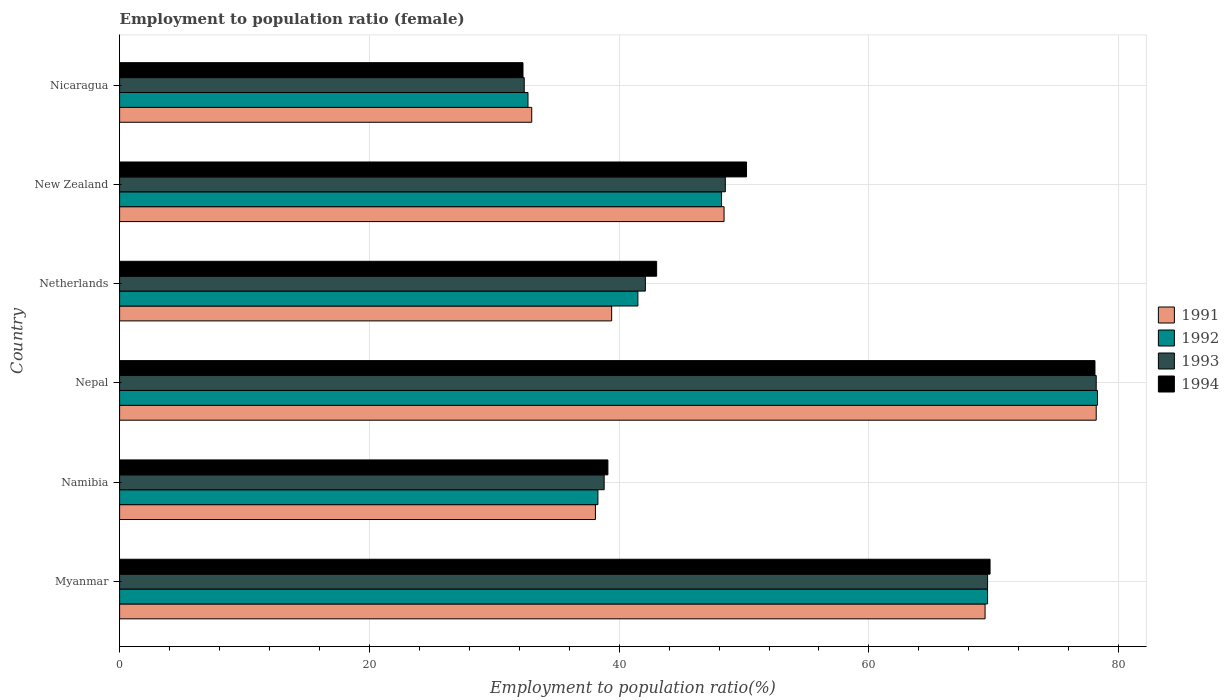Are the number of bars per tick equal to the number of legend labels?
Your answer should be compact. Yes. Are the number of bars on each tick of the Y-axis equal?
Keep it short and to the point. Yes. How many bars are there on the 3rd tick from the bottom?
Give a very brief answer. 4. What is the label of the 6th group of bars from the top?
Provide a succinct answer. Myanmar. In how many cases, is the number of bars for a given country not equal to the number of legend labels?
Make the answer very short. 0. What is the employment to population ratio in 1994 in Myanmar?
Make the answer very short. 69.7. Across all countries, what is the maximum employment to population ratio in 1994?
Offer a terse response. 78.1. Across all countries, what is the minimum employment to population ratio in 1993?
Give a very brief answer. 32.4. In which country was the employment to population ratio in 1993 maximum?
Offer a terse response. Nepal. In which country was the employment to population ratio in 1991 minimum?
Your answer should be very brief. Nicaragua. What is the total employment to population ratio in 1992 in the graph?
Offer a very short reply. 308.5. What is the difference between the employment to population ratio in 1992 in Namibia and that in New Zealand?
Offer a terse response. -9.9. What is the difference between the employment to population ratio in 1993 in Namibia and the employment to population ratio in 1994 in Netherlands?
Your answer should be very brief. -4.2. What is the average employment to population ratio in 1994 per country?
Make the answer very short. 52.07. What is the ratio of the employment to population ratio in 1993 in Myanmar to that in New Zealand?
Ensure brevity in your answer.  1.43. Is the difference between the employment to population ratio in 1992 in Myanmar and Nepal greater than the difference between the employment to population ratio in 1993 in Myanmar and Nepal?
Offer a terse response. No. What is the difference between the highest and the second highest employment to population ratio in 1993?
Your answer should be very brief. 8.7. What is the difference between the highest and the lowest employment to population ratio in 1991?
Your answer should be compact. 45.2. Is the sum of the employment to population ratio in 1994 in Namibia and Nicaragua greater than the maximum employment to population ratio in 1992 across all countries?
Your answer should be compact. No. What does the 2nd bar from the top in Nepal represents?
Provide a short and direct response. 1993. How many bars are there?
Offer a terse response. 24. Are all the bars in the graph horizontal?
Ensure brevity in your answer.  Yes. How many countries are there in the graph?
Provide a short and direct response. 6. Does the graph contain grids?
Ensure brevity in your answer.  Yes. How many legend labels are there?
Provide a short and direct response. 4. What is the title of the graph?
Your answer should be compact. Employment to population ratio (female). Does "1987" appear as one of the legend labels in the graph?
Make the answer very short. No. What is the label or title of the X-axis?
Your response must be concise. Employment to population ratio(%). What is the label or title of the Y-axis?
Your answer should be compact. Country. What is the Employment to population ratio(%) of 1991 in Myanmar?
Ensure brevity in your answer.  69.3. What is the Employment to population ratio(%) of 1992 in Myanmar?
Make the answer very short. 69.5. What is the Employment to population ratio(%) of 1993 in Myanmar?
Give a very brief answer. 69.5. What is the Employment to population ratio(%) in 1994 in Myanmar?
Your answer should be compact. 69.7. What is the Employment to population ratio(%) of 1991 in Namibia?
Your answer should be very brief. 38.1. What is the Employment to population ratio(%) of 1992 in Namibia?
Provide a succinct answer. 38.3. What is the Employment to population ratio(%) in 1993 in Namibia?
Offer a very short reply. 38.8. What is the Employment to population ratio(%) in 1994 in Namibia?
Make the answer very short. 39.1. What is the Employment to population ratio(%) in 1991 in Nepal?
Provide a short and direct response. 78.2. What is the Employment to population ratio(%) in 1992 in Nepal?
Your answer should be compact. 78.3. What is the Employment to population ratio(%) of 1993 in Nepal?
Make the answer very short. 78.2. What is the Employment to population ratio(%) of 1994 in Nepal?
Provide a succinct answer. 78.1. What is the Employment to population ratio(%) of 1991 in Netherlands?
Your answer should be compact. 39.4. What is the Employment to population ratio(%) in 1992 in Netherlands?
Keep it short and to the point. 41.5. What is the Employment to population ratio(%) of 1993 in Netherlands?
Provide a short and direct response. 42.1. What is the Employment to population ratio(%) in 1991 in New Zealand?
Provide a succinct answer. 48.4. What is the Employment to population ratio(%) of 1992 in New Zealand?
Your answer should be compact. 48.2. What is the Employment to population ratio(%) in 1993 in New Zealand?
Give a very brief answer. 48.5. What is the Employment to population ratio(%) of 1994 in New Zealand?
Keep it short and to the point. 50.2. What is the Employment to population ratio(%) of 1992 in Nicaragua?
Ensure brevity in your answer.  32.7. What is the Employment to population ratio(%) of 1993 in Nicaragua?
Provide a succinct answer. 32.4. What is the Employment to population ratio(%) of 1994 in Nicaragua?
Provide a short and direct response. 32.3. Across all countries, what is the maximum Employment to population ratio(%) in 1991?
Make the answer very short. 78.2. Across all countries, what is the maximum Employment to population ratio(%) of 1992?
Your answer should be very brief. 78.3. Across all countries, what is the maximum Employment to population ratio(%) in 1993?
Make the answer very short. 78.2. Across all countries, what is the maximum Employment to population ratio(%) of 1994?
Make the answer very short. 78.1. Across all countries, what is the minimum Employment to population ratio(%) in 1992?
Make the answer very short. 32.7. Across all countries, what is the minimum Employment to population ratio(%) in 1993?
Provide a succinct answer. 32.4. Across all countries, what is the minimum Employment to population ratio(%) of 1994?
Give a very brief answer. 32.3. What is the total Employment to population ratio(%) of 1991 in the graph?
Provide a short and direct response. 306.4. What is the total Employment to population ratio(%) in 1992 in the graph?
Offer a terse response. 308.5. What is the total Employment to population ratio(%) in 1993 in the graph?
Your answer should be very brief. 309.5. What is the total Employment to population ratio(%) in 1994 in the graph?
Provide a short and direct response. 312.4. What is the difference between the Employment to population ratio(%) of 1991 in Myanmar and that in Namibia?
Give a very brief answer. 31.2. What is the difference between the Employment to population ratio(%) in 1992 in Myanmar and that in Namibia?
Make the answer very short. 31.2. What is the difference between the Employment to population ratio(%) of 1993 in Myanmar and that in Namibia?
Your answer should be compact. 30.7. What is the difference between the Employment to population ratio(%) in 1994 in Myanmar and that in Namibia?
Offer a terse response. 30.6. What is the difference between the Employment to population ratio(%) in 1991 in Myanmar and that in Nepal?
Provide a succinct answer. -8.9. What is the difference between the Employment to population ratio(%) in 1992 in Myanmar and that in Nepal?
Give a very brief answer. -8.8. What is the difference between the Employment to population ratio(%) in 1991 in Myanmar and that in Netherlands?
Your response must be concise. 29.9. What is the difference between the Employment to population ratio(%) of 1992 in Myanmar and that in Netherlands?
Your response must be concise. 28. What is the difference between the Employment to population ratio(%) of 1993 in Myanmar and that in Netherlands?
Provide a short and direct response. 27.4. What is the difference between the Employment to population ratio(%) in 1994 in Myanmar and that in Netherlands?
Keep it short and to the point. 26.7. What is the difference between the Employment to population ratio(%) of 1991 in Myanmar and that in New Zealand?
Ensure brevity in your answer.  20.9. What is the difference between the Employment to population ratio(%) of 1992 in Myanmar and that in New Zealand?
Ensure brevity in your answer.  21.3. What is the difference between the Employment to population ratio(%) of 1993 in Myanmar and that in New Zealand?
Provide a short and direct response. 21. What is the difference between the Employment to population ratio(%) in 1994 in Myanmar and that in New Zealand?
Your answer should be compact. 19.5. What is the difference between the Employment to population ratio(%) in 1991 in Myanmar and that in Nicaragua?
Give a very brief answer. 36.3. What is the difference between the Employment to population ratio(%) in 1992 in Myanmar and that in Nicaragua?
Your answer should be compact. 36.8. What is the difference between the Employment to population ratio(%) of 1993 in Myanmar and that in Nicaragua?
Provide a succinct answer. 37.1. What is the difference between the Employment to population ratio(%) in 1994 in Myanmar and that in Nicaragua?
Your response must be concise. 37.4. What is the difference between the Employment to population ratio(%) of 1991 in Namibia and that in Nepal?
Keep it short and to the point. -40.1. What is the difference between the Employment to population ratio(%) in 1992 in Namibia and that in Nepal?
Provide a short and direct response. -40. What is the difference between the Employment to population ratio(%) in 1993 in Namibia and that in Nepal?
Ensure brevity in your answer.  -39.4. What is the difference between the Employment to population ratio(%) of 1994 in Namibia and that in Nepal?
Provide a short and direct response. -39. What is the difference between the Employment to population ratio(%) of 1991 in Namibia and that in Netherlands?
Offer a terse response. -1.3. What is the difference between the Employment to population ratio(%) of 1992 in Namibia and that in Netherlands?
Make the answer very short. -3.2. What is the difference between the Employment to population ratio(%) in 1993 in Namibia and that in Netherlands?
Your response must be concise. -3.3. What is the difference between the Employment to population ratio(%) of 1992 in Namibia and that in New Zealand?
Provide a short and direct response. -9.9. What is the difference between the Employment to population ratio(%) of 1993 in Namibia and that in New Zealand?
Provide a short and direct response. -9.7. What is the difference between the Employment to population ratio(%) of 1992 in Namibia and that in Nicaragua?
Offer a very short reply. 5.6. What is the difference between the Employment to population ratio(%) in 1994 in Namibia and that in Nicaragua?
Your answer should be very brief. 6.8. What is the difference between the Employment to population ratio(%) in 1991 in Nepal and that in Netherlands?
Your response must be concise. 38.8. What is the difference between the Employment to population ratio(%) of 1992 in Nepal and that in Netherlands?
Your answer should be compact. 36.8. What is the difference between the Employment to population ratio(%) in 1993 in Nepal and that in Netherlands?
Give a very brief answer. 36.1. What is the difference between the Employment to population ratio(%) of 1994 in Nepal and that in Netherlands?
Provide a short and direct response. 35.1. What is the difference between the Employment to population ratio(%) in 1991 in Nepal and that in New Zealand?
Provide a succinct answer. 29.8. What is the difference between the Employment to population ratio(%) of 1992 in Nepal and that in New Zealand?
Offer a very short reply. 30.1. What is the difference between the Employment to population ratio(%) in 1993 in Nepal and that in New Zealand?
Make the answer very short. 29.7. What is the difference between the Employment to population ratio(%) in 1994 in Nepal and that in New Zealand?
Offer a very short reply. 27.9. What is the difference between the Employment to population ratio(%) in 1991 in Nepal and that in Nicaragua?
Your answer should be compact. 45.2. What is the difference between the Employment to population ratio(%) of 1992 in Nepal and that in Nicaragua?
Your response must be concise. 45.6. What is the difference between the Employment to population ratio(%) of 1993 in Nepal and that in Nicaragua?
Give a very brief answer. 45.8. What is the difference between the Employment to population ratio(%) of 1994 in Nepal and that in Nicaragua?
Offer a very short reply. 45.8. What is the difference between the Employment to population ratio(%) in 1991 in Netherlands and that in New Zealand?
Ensure brevity in your answer.  -9. What is the difference between the Employment to population ratio(%) in 1993 in Netherlands and that in New Zealand?
Provide a succinct answer. -6.4. What is the difference between the Employment to population ratio(%) of 1994 in Netherlands and that in New Zealand?
Give a very brief answer. -7.2. What is the difference between the Employment to population ratio(%) of 1991 in Netherlands and that in Nicaragua?
Offer a very short reply. 6.4. What is the difference between the Employment to population ratio(%) in 1992 in New Zealand and that in Nicaragua?
Ensure brevity in your answer.  15.5. What is the difference between the Employment to population ratio(%) in 1991 in Myanmar and the Employment to population ratio(%) in 1993 in Namibia?
Make the answer very short. 30.5. What is the difference between the Employment to population ratio(%) in 1991 in Myanmar and the Employment to population ratio(%) in 1994 in Namibia?
Provide a succinct answer. 30.2. What is the difference between the Employment to population ratio(%) in 1992 in Myanmar and the Employment to population ratio(%) in 1993 in Namibia?
Make the answer very short. 30.7. What is the difference between the Employment to population ratio(%) in 1992 in Myanmar and the Employment to population ratio(%) in 1994 in Namibia?
Your answer should be very brief. 30.4. What is the difference between the Employment to population ratio(%) in 1993 in Myanmar and the Employment to population ratio(%) in 1994 in Namibia?
Provide a short and direct response. 30.4. What is the difference between the Employment to population ratio(%) in 1991 in Myanmar and the Employment to population ratio(%) in 1992 in Nepal?
Provide a short and direct response. -9. What is the difference between the Employment to population ratio(%) in 1991 in Myanmar and the Employment to population ratio(%) in 1993 in Nepal?
Ensure brevity in your answer.  -8.9. What is the difference between the Employment to population ratio(%) in 1992 in Myanmar and the Employment to population ratio(%) in 1994 in Nepal?
Your response must be concise. -8.6. What is the difference between the Employment to population ratio(%) of 1993 in Myanmar and the Employment to population ratio(%) of 1994 in Nepal?
Ensure brevity in your answer.  -8.6. What is the difference between the Employment to population ratio(%) in 1991 in Myanmar and the Employment to population ratio(%) in 1992 in Netherlands?
Provide a short and direct response. 27.8. What is the difference between the Employment to population ratio(%) in 1991 in Myanmar and the Employment to population ratio(%) in 1993 in Netherlands?
Give a very brief answer. 27.2. What is the difference between the Employment to population ratio(%) of 1991 in Myanmar and the Employment to population ratio(%) of 1994 in Netherlands?
Your response must be concise. 26.3. What is the difference between the Employment to population ratio(%) of 1992 in Myanmar and the Employment to population ratio(%) of 1993 in Netherlands?
Ensure brevity in your answer.  27.4. What is the difference between the Employment to population ratio(%) in 1992 in Myanmar and the Employment to population ratio(%) in 1994 in Netherlands?
Provide a succinct answer. 26.5. What is the difference between the Employment to population ratio(%) in 1991 in Myanmar and the Employment to population ratio(%) in 1992 in New Zealand?
Provide a short and direct response. 21.1. What is the difference between the Employment to population ratio(%) in 1991 in Myanmar and the Employment to population ratio(%) in 1993 in New Zealand?
Keep it short and to the point. 20.8. What is the difference between the Employment to population ratio(%) of 1992 in Myanmar and the Employment to population ratio(%) of 1994 in New Zealand?
Give a very brief answer. 19.3. What is the difference between the Employment to population ratio(%) of 1993 in Myanmar and the Employment to population ratio(%) of 1994 in New Zealand?
Your answer should be compact. 19.3. What is the difference between the Employment to population ratio(%) of 1991 in Myanmar and the Employment to population ratio(%) of 1992 in Nicaragua?
Make the answer very short. 36.6. What is the difference between the Employment to population ratio(%) in 1991 in Myanmar and the Employment to population ratio(%) in 1993 in Nicaragua?
Your answer should be compact. 36.9. What is the difference between the Employment to population ratio(%) in 1991 in Myanmar and the Employment to population ratio(%) in 1994 in Nicaragua?
Your answer should be very brief. 37. What is the difference between the Employment to population ratio(%) in 1992 in Myanmar and the Employment to population ratio(%) in 1993 in Nicaragua?
Ensure brevity in your answer.  37.1. What is the difference between the Employment to population ratio(%) in 1992 in Myanmar and the Employment to population ratio(%) in 1994 in Nicaragua?
Your answer should be very brief. 37.2. What is the difference between the Employment to population ratio(%) in 1993 in Myanmar and the Employment to population ratio(%) in 1994 in Nicaragua?
Give a very brief answer. 37.2. What is the difference between the Employment to population ratio(%) of 1991 in Namibia and the Employment to population ratio(%) of 1992 in Nepal?
Keep it short and to the point. -40.2. What is the difference between the Employment to population ratio(%) in 1991 in Namibia and the Employment to population ratio(%) in 1993 in Nepal?
Give a very brief answer. -40.1. What is the difference between the Employment to population ratio(%) in 1992 in Namibia and the Employment to population ratio(%) in 1993 in Nepal?
Provide a short and direct response. -39.9. What is the difference between the Employment to population ratio(%) of 1992 in Namibia and the Employment to population ratio(%) of 1994 in Nepal?
Provide a short and direct response. -39.8. What is the difference between the Employment to population ratio(%) in 1993 in Namibia and the Employment to population ratio(%) in 1994 in Nepal?
Give a very brief answer. -39.3. What is the difference between the Employment to population ratio(%) in 1991 in Namibia and the Employment to population ratio(%) in 1992 in Netherlands?
Your answer should be very brief. -3.4. What is the difference between the Employment to population ratio(%) of 1991 in Namibia and the Employment to population ratio(%) of 1994 in Netherlands?
Your answer should be very brief. -4.9. What is the difference between the Employment to population ratio(%) of 1992 in Namibia and the Employment to population ratio(%) of 1993 in Netherlands?
Provide a short and direct response. -3.8. What is the difference between the Employment to population ratio(%) in 1993 in Namibia and the Employment to population ratio(%) in 1994 in Netherlands?
Offer a very short reply. -4.2. What is the difference between the Employment to population ratio(%) in 1991 in Namibia and the Employment to population ratio(%) in 1994 in New Zealand?
Provide a short and direct response. -12.1. What is the difference between the Employment to population ratio(%) in 1992 in Namibia and the Employment to population ratio(%) in 1993 in New Zealand?
Your answer should be very brief. -10.2. What is the difference between the Employment to population ratio(%) in 1991 in Namibia and the Employment to population ratio(%) in 1994 in Nicaragua?
Make the answer very short. 5.8. What is the difference between the Employment to population ratio(%) of 1992 in Namibia and the Employment to population ratio(%) of 1994 in Nicaragua?
Offer a very short reply. 6. What is the difference between the Employment to population ratio(%) of 1993 in Namibia and the Employment to population ratio(%) of 1994 in Nicaragua?
Give a very brief answer. 6.5. What is the difference between the Employment to population ratio(%) in 1991 in Nepal and the Employment to population ratio(%) in 1992 in Netherlands?
Provide a short and direct response. 36.7. What is the difference between the Employment to population ratio(%) of 1991 in Nepal and the Employment to population ratio(%) of 1993 in Netherlands?
Keep it short and to the point. 36.1. What is the difference between the Employment to population ratio(%) in 1991 in Nepal and the Employment to population ratio(%) in 1994 in Netherlands?
Your response must be concise. 35.2. What is the difference between the Employment to population ratio(%) in 1992 in Nepal and the Employment to population ratio(%) in 1993 in Netherlands?
Provide a succinct answer. 36.2. What is the difference between the Employment to population ratio(%) of 1992 in Nepal and the Employment to population ratio(%) of 1994 in Netherlands?
Make the answer very short. 35.3. What is the difference between the Employment to population ratio(%) of 1993 in Nepal and the Employment to population ratio(%) of 1994 in Netherlands?
Offer a very short reply. 35.2. What is the difference between the Employment to population ratio(%) of 1991 in Nepal and the Employment to population ratio(%) of 1992 in New Zealand?
Give a very brief answer. 30. What is the difference between the Employment to population ratio(%) of 1991 in Nepal and the Employment to population ratio(%) of 1993 in New Zealand?
Make the answer very short. 29.7. What is the difference between the Employment to population ratio(%) of 1991 in Nepal and the Employment to population ratio(%) of 1994 in New Zealand?
Your answer should be compact. 28. What is the difference between the Employment to population ratio(%) of 1992 in Nepal and the Employment to population ratio(%) of 1993 in New Zealand?
Offer a terse response. 29.8. What is the difference between the Employment to population ratio(%) in 1992 in Nepal and the Employment to population ratio(%) in 1994 in New Zealand?
Your answer should be compact. 28.1. What is the difference between the Employment to population ratio(%) in 1991 in Nepal and the Employment to population ratio(%) in 1992 in Nicaragua?
Provide a short and direct response. 45.5. What is the difference between the Employment to population ratio(%) of 1991 in Nepal and the Employment to population ratio(%) of 1993 in Nicaragua?
Your answer should be very brief. 45.8. What is the difference between the Employment to population ratio(%) of 1991 in Nepal and the Employment to population ratio(%) of 1994 in Nicaragua?
Ensure brevity in your answer.  45.9. What is the difference between the Employment to population ratio(%) in 1992 in Nepal and the Employment to population ratio(%) in 1993 in Nicaragua?
Give a very brief answer. 45.9. What is the difference between the Employment to population ratio(%) in 1993 in Nepal and the Employment to population ratio(%) in 1994 in Nicaragua?
Give a very brief answer. 45.9. What is the difference between the Employment to population ratio(%) in 1991 in Netherlands and the Employment to population ratio(%) in 1994 in New Zealand?
Your answer should be very brief. -10.8. What is the difference between the Employment to population ratio(%) of 1991 in Netherlands and the Employment to population ratio(%) of 1993 in Nicaragua?
Provide a succinct answer. 7. What is the difference between the Employment to population ratio(%) in 1992 in Netherlands and the Employment to population ratio(%) in 1994 in Nicaragua?
Provide a succinct answer. 9.2. What is the difference between the Employment to population ratio(%) in 1993 in Netherlands and the Employment to population ratio(%) in 1994 in Nicaragua?
Your answer should be very brief. 9.8. What is the difference between the Employment to population ratio(%) of 1991 in New Zealand and the Employment to population ratio(%) of 1992 in Nicaragua?
Offer a terse response. 15.7. What is the difference between the Employment to population ratio(%) in 1991 in New Zealand and the Employment to population ratio(%) in 1994 in Nicaragua?
Ensure brevity in your answer.  16.1. What is the difference between the Employment to population ratio(%) in 1992 in New Zealand and the Employment to population ratio(%) in 1994 in Nicaragua?
Offer a very short reply. 15.9. What is the difference between the Employment to population ratio(%) of 1993 in New Zealand and the Employment to population ratio(%) of 1994 in Nicaragua?
Offer a terse response. 16.2. What is the average Employment to population ratio(%) of 1991 per country?
Keep it short and to the point. 51.07. What is the average Employment to population ratio(%) of 1992 per country?
Keep it short and to the point. 51.42. What is the average Employment to population ratio(%) of 1993 per country?
Offer a terse response. 51.58. What is the average Employment to population ratio(%) of 1994 per country?
Ensure brevity in your answer.  52.07. What is the difference between the Employment to population ratio(%) of 1991 and Employment to population ratio(%) of 1992 in Myanmar?
Your response must be concise. -0.2. What is the difference between the Employment to population ratio(%) of 1991 and Employment to population ratio(%) of 1993 in Myanmar?
Provide a short and direct response. -0.2. What is the difference between the Employment to population ratio(%) in 1992 and Employment to population ratio(%) in 1993 in Myanmar?
Offer a very short reply. 0. What is the difference between the Employment to population ratio(%) in 1993 and Employment to population ratio(%) in 1994 in Myanmar?
Your answer should be compact. -0.2. What is the difference between the Employment to population ratio(%) of 1991 and Employment to population ratio(%) of 1994 in Namibia?
Your answer should be very brief. -1. What is the difference between the Employment to population ratio(%) of 1993 and Employment to population ratio(%) of 1994 in Namibia?
Give a very brief answer. -0.3. What is the difference between the Employment to population ratio(%) of 1991 and Employment to population ratio(%) of 1992 in Nepal?
Provide a short and direct response. -0.1. What is the difference between the Employment to population ratio(%) in 1991 and Employment to population ratio(%) in 1994 in Nepal?
Give a very brief answer. 0.1. What is the difference between the Employment to population ratio(%) in 1992 and Employment to population ratio(%) in 1993 in Nepal?
Offer a very short reply. 0.1. What is the difference between the Employment to population ratio(%) in 1993 and Employment to population ratio(%) in 1994 in Nepal?
Give a very brief answer. 0.1. What is the difference between the Employment to population ratio(%) in 1991 and Employment to population ratio(%) in 1994 in Netherlands?
Offer a terse response. -3.6. What is the difference between the Employment to population ratio(%) in 1992 and Employment to population ratio(%) in 1994 in Netherlands?
Your answer should be very brief. -1.5. What is the difference between the Employment to population ratio(%) of 1993 and Employment to population ratio(%) of 1994 in Netherlands?
Your answer should be very brief. -0.9. What is the difference between the Employment to population ratio(%) of 1991 and Employment to population ratio(%) of 1994 in New Zealand?
Make the answer very short. -1.8. What is the difference between the Employment to population ratio(%) of 1993 and Employment to population ratio(%) of 1994 in New Zealand?
Offer a terse response. -1.7. What is the difference between the Employment to population ratio(%) in 1991 and Employment to population ratio(%) in 1992 in Nicaragua?
Keep it short and to the point. 0.3. What is the difference between the Employment to population ratio(%) in 1991 and Employment to population ratio(%) in 1993 in Nicaragua?
Offer a terse response. 0.6. What is the difference between the Employment to population ratio(%) of 1992 and Employment to population ratio(%) of 1994 in Nicaragua?
Make the answer very short. 0.4. What is the ratio of the Employment to population ratio(%) of 1991 in Myanmar to that in Namibia?
Keep it short and to the point. 1.82. What is the ratio of the Employment to population ratio(%) of 1992 in Myanmar to that in Namibia?
Keep it short and to the point. 1.81. What is the ratio of the Employment to population ratio(%) in 1993 in Myanmar to that in Namibia?
Make the answer very short. 1.79. What is the ratio of the Employment to population ratio(%) of 1994 in Myanmar to that in Namibia?
Your answer should be very brief. 1.78. What is the ratio of the Employment to population ratio(%) of 1991 in Myanmar to that in Nepal?
Your answer should be very brief. 0.89. What is the ratio of the Employment to population ratio(%) of 1992 in Myanmar to that in Nepal?
Provide a short and direct response. 0.89. What is the ratio of the Employment to population ratio(%) of 1993 in Myanmar to that in Nepal?
Make the answer very short. 0.89. What is the ratio of the Employment to population ratio(%) in 1994 in Myanmar to that in Nepal?
Make the answer very short. 0.89. What is the ratio of the Employment to population ratio(%) of 1991 in Myanmar to that in Netherlands?
Ensure brevity in your answer.  1.76. What is the ratio of the Employment to population ratio(%) of 1992 in Myanmar to that in Netherlands?
Provide a succinct answer. 1.67. What is the ratio of the Employment to population ratio(%) in 1993 in Myanmar to that in Netherlands?
Provide a short and direct response. 1.65. What is the ratio of the Employment to population ratio(%) of 1994 in Myanmar to that in Netherlands?
Provide a succinct answer. 1.62. What is the ratio of the Employment to population ratio(%) in 1991 in Myanmar to that in New Zealand?
Provide a short and direct response. 1.43. What is the ratio of the Employment to population ratio(%) of 1992 in Myanmar to that in New Zealand?
Keep it short and to the point. 1.44. What is the ratio of the Employment to population ratio(%) in 1993 in Myanmar to that in New Zealand?
Offer a terse response. 1.43. What is the ratio of the Employment to population ratio(%) in 1994 in Myanmar to that in New Zealand?
Provide a succinct answer. 1.39. What is the ratio of the Employment to population ratio(%) in 1991 in Myanmar to that in Nicaragua?
Your response must be concise. 2.1. What is the ratio of the Employment to population ratio(%) in 1992 in Myanmar to that in Nicaragua?
Give a very brief answer. 2.13. What is the ratio of the Employment to population ratio(%) of 1993 in Myanmar to that in Nicaragua?
Provide a short and direct response. 2.15. What is the ratio of the Employment to population ratio(%) of 1994 in Myanmar to that in Nicaragua?
Your answer should be compact. 2.16. What is the ratio of the Employment to population ratio(%) in 1991 in Namibia to that in Nepal?
Your answer should be compact. 0.49. What is the ratio of the Employment to population ratio(%) of 1992 in Namibia to that in Nepal?
Provide a short and direct response. 0.49. What is the ratio of the Employment to population ratio(%) in 1993 in Namibia to that in Nepal?
Your answer should be very brief. 0.5. What is the ratio of the Employment to population ratio(%) in 1994 in Namibia to that in Nepal?
Keep it short and to the point. 0.5. What is the ratio of the Employment to population ratio(%) of 1991 in Namibia to that in Netherlands?
Ensure brevity in your answer.  0.97. What is the ratio of the Employment to population ratio(%) of 1992 in Namibia to that in Netherlands?
Provide a succinct answer. 0.92. What is the ratio of the Employment to population ratio(%) in 1993 in Namibia to that in Netherlands?
Make the answer very short. 0.92. What is the ratio of the Employment to population ratio(%) in 1994 in Namibia to that in Netherlands?
Keep it short and to the point. 0.91. What is the ratio of the Employment to population ratio(%) of 1991 in Namibia to that in New Zealand?
Provide a succinct answer. 0.79. What is the ratio of the Employment to population ratio(%) of 1992 in Namibia to that in New Zealand?
Your response must be concise. 0.79. What is the ratio of the Employment to population ratio(%) in 1993 in Namibia to that in New Zealand?
Ensure brevity in your answer.  0.8. What is the ratio of the Employment to population ratio(%) of 1994 in Namibia to that in New Zealand?
Provide a short and direct response. 0.78. What is the ratio of the Employment to population ratio(%) in 1991 in Namibia to that in Nicaragua?
Offer a very short reply. 1.15. What is the ratio of the Employment to population ratio(%) in 1992 in Namibia to that in Nicaragua?
Keep it short and to the point. 1.17. What is the ratio of the Employment to population ratio(%) of 1993 in Namibia to that in Nicaragua?
Give a very brief answer. 1.2. What is the ratio of the Employment to population ratio(%) in 1994 in Namibia to that in Nicaragua?
Provide a succinct answer. 1.21. What is the ratio of the Employment to population ratio(%) of 1991 in Nepal to that in Netherlands?
Offer a very short reply. 1.98. What is the ratio of the Employment to population ratio(%) in 1992 in Nepal to that in Netherlands?
Keep it short and to the point. 1.89. What is the ratio of the Employment to population ratio(%) of 1993 in Nepal to that in Netherlands?
Keep it short and to the point. 1.86. What is the ratio of the Employment to population ratio(%) in 1994 in Nepal to that in Netherlands?
Offer a very short reply. 1.82. What is the ratio of the Employment to population ratio(%) in 1991 in Nepal to that in New Zealand?
Give a very brief answer. 1.62. What is the ratio of the Employment to population ratio(%) of 1992 in Nepal to that in New Zealand?
Keep it short and to the point. 1.62. What is the ratio of the Employment to population ratio(%) in 1993 in Nepal to that in New Zealand?
Make the answer very short. 1.61. What is the ratio of the Employment to population ratio(%) of 1994 in Nepal to that in New Zealand?
Offer a very short reply. 1.56. What is the ratio of the Employment to population ratio(%) in 1991 in Nepal to that in Nicaragua?
Your answer should be very brief. 2.37. What is the ratio of the Employment to population ratio(%) of 1992 in Nepal to that in Nicaragua?
Your answer should be compact. 2.39. What is the ratio of the Employment to population ratio(%) in 1993 in Nepal to that in Nicaragua?
Ensure brevity in your answer.  2.41. What is the ratio of the Employment to population ratio(%) of 1994 in Nepal to that in Nicaragua?
Offer a very short reply. 2.42. What is the ratio of the Employment to population ratio(%) of 1991 in Netherlands to that in New Zealand?
Your response must be concise. 0.81. What is the ratio of the Employment to population ratio(%) in 1992 in Netherlands to that in New Zealand?
Your response must be concise. 0.86. What is the ratio of the Employment to population ratio(%) in 1993 in Netherlands to that in New Zealand?
Your response must be concise. 0.87. What is the ratio of the Employment to population ratio(%) of 1994 in Netherlands to that in New Zealand?
Give a very brief answer. 0.86. What is the ratio of the Employment to population ratio(%) in 1991 in Netherlands to that in Nicaragua?
Make the answer very short. 1.19. What is the ratio of the Employment to population ratio(%) in 1992 in Netherlands to that in Nicaragua?
Offer a terse response. 1.27. What is the ratio of the Employment to population ratio(%) of 1993 in Netherlands to that in Nicaragua?
Your answer should be very brief. 1.3. What is the ratio of the Employment to population ratio(%) in 1994 in Netherlands to that in Nicaragua?
Keep it short and to the point. 1.33. What is the ratio of the Employment to population ratio(%) of 1991 in New Zealand to that in Nicaragua?
Provide a short and direct response. 1.47. What is the ratio of the Employment to population ratio(%) in 1992 in New Zealand to that in Nicaragua?
Give a very brief answer. 1.47. What is the ratio of the Employment to population ratio(%) in 1993 in New Zealand to that in Nicaragua?
Your answer should be compact. 1.5. What is the ratio of the Employment to population ratio(%) of 1994 in New Zealand to that in Nicaragua?
Make the answer very short. 1.55. What is the difference between the highest and the second highest Employment to population ratio(%) in 1991?
Your answer should be compact. 8.9. What is the difference between the highest and the second highest Employment to population ratio(%) of 1992?
Your response must be concise. 8.8. What is the difference between the highest and the second highest Employment to population ratio(%) in 1993?
Offer a very short reply. 8.7. What is the difference between the highest and the lowest Employment to population ratio(%) in 1991?
Offer a terse response. 45.2. What is the difference between the highest and the lowest Employment to population ratio(%) in 1992?
Provide a short and direct response. 45.6. What is the difference between the highest and the lowest Employment to population ratio(%) of 1993?
Provide a short and direct response. 45.8. What is the difference between the highest and the lowest Employment to population ratio(%) in 1994?
Your answer should be very brief. 45.8. 